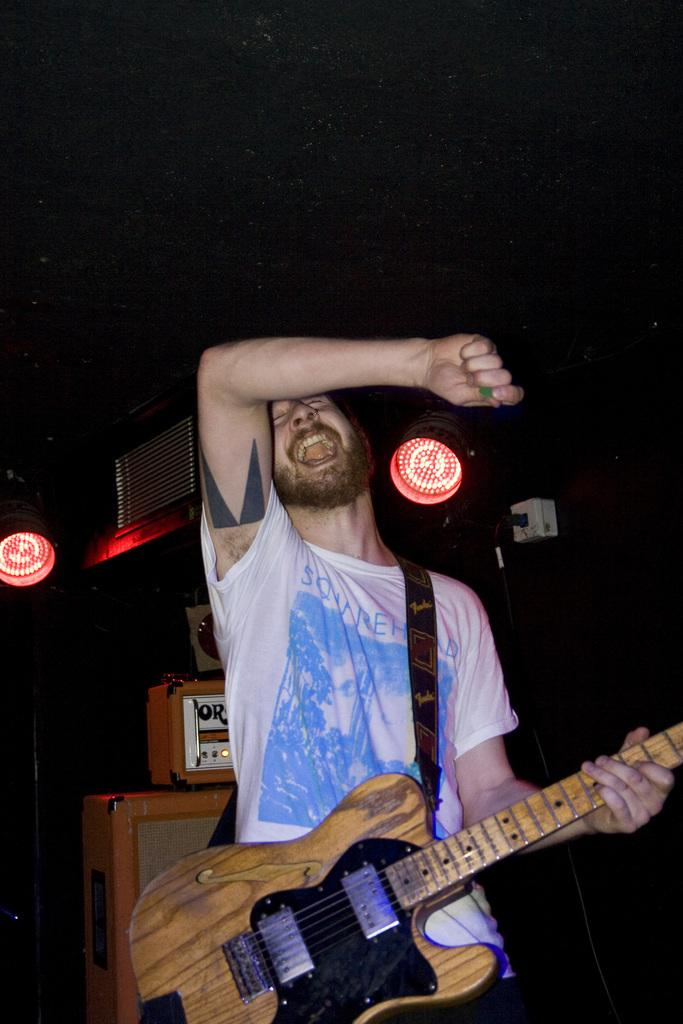What is the overall color scheme of the image? The background of the image is dark. What can be seen in the image besides the dark background? There are lights visible in the image. What object is present in the image that might be used for a specific purpose? There is a device in the image. Who is in the image, and what is he doing? There is a man standing in the image, and he is holding a guitar in his hand. Can you tell me how many degrees the water in the image is? There is no water present in the image, so it is not possible to determine the temperature or degrees of any water. 